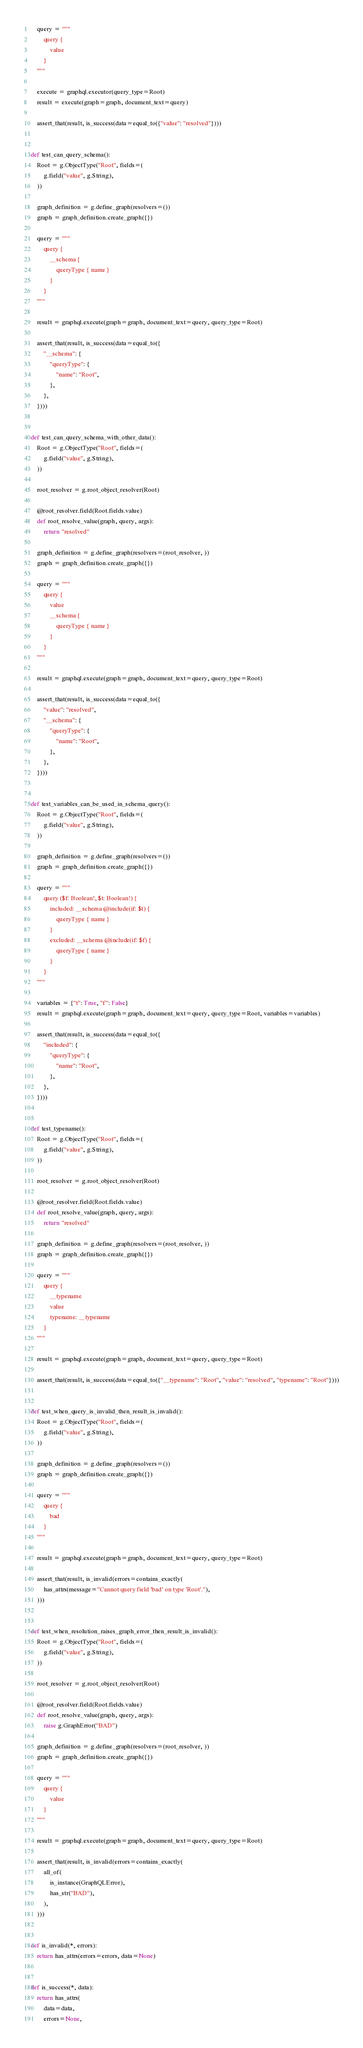Convert code to text. <code><loc_0><loc_0><loc_500><loc_500><_Python_>    query = """
        query {
            value
        }
    """

    execute = graphql.executor(query_type=Root)
    result = execute(graph=graph, document_text=query)

    assert_that(result, is_success(data=equal_to({"value": "resolved"})))


def test_can_query_schema():
    Root = g.ObjectType("Root", fields=(
        g.field("value", g.String),
    ))

    graph_definition = g.define_graph(resolvers=())
    graph = graph_definition.create_graph({})

    query = """
        query {
            __schema {
                queryType { name }
            }
        }
    """

    result = graphql.execute(graph=graph, document_text=query, query_type=Root)

    assert_that(result, is_success(data=equal_to({
        "__schema": {
            "queryType": {
                "name": "Root",
            },
        },
    })))


def test_can_query_schema_with_other_data():
    Root = g.ObjectType("Root", fields=(
        g.field("value", g.String),
    ))

    root_resolver = g.root_object_resolver(Root)

    @root_resolver.field(Root.fields.value)
    def root_resolve_value(graph, query, args):
        return "resolved"

    graph_definition = g.define_graph(resolvers=(root_resolver, ))
    graph = graph_definition.create_graph({})

    query = """
        query {
            value
            __schema {
                queryType { name }
            }
        }
    """

    result = graphql.execute(graph=graph, document_text=query, query_type=Root)

    assert_that(result, is_success(data=equal_to({
        "value": "resolved",
        "__schema": {
            "queryType": {
                "name": "Root",
            },
        },
    })))


def test_variables_can_be_used_in_schema_query():
    Root = g.ObjectType("Root", fields=(
        g.field("value", g.String),
    ))

    graph_definition = g.define_graph(resolvers=())
    graph = graph_definition.create_graph({})

    query = """
        query ($f: Boolean!, $t: Boolean!) {
            included: __schema @include(if: $t) {
                queryType { name }
            }
            excluded: __schema @include(if: $f) {
                queryType { name }
            }
        }
    """

    variables = {"t": True, "f": False}
    result = graphql.execute(graph=graph, document_text=query, query_type=Root, variables=variables)

    assert_that(result, is_success(data=equal_to({
        "included": {
            "queryType": {
                "name": "Root",
            },
        },
    })))


def test_typename():
    Root = g.ObjectType("Root", fields=(
        g.field("value", g.String),
    ))

    root_resolver = g.root_object_resolver(Root)

    @root_resolver.field(Root.fields.value)
    def root_resolve_value(graph, query, args):
        return "resolved"

    graph_definition = g.define_graph(resolvers=(root_resolver, ))
    graph = graph_definition.create_graph({})

    query = """
        query {
            __typename
            value
            typename: __typename
        }
    """

    result = graphql.execute(graph=graph, document_text=query, query_type=Root)

    assert_that(result, is_success(data=equal_to({"__typename": "Root", "value": "resolved", "typename": "Root"})))


def test_when_query_is_invalid_then_result_is_invalid():
    Root = g.ObjectType("Root", fields=(
        g.field("value", g.String),
    ))

    graph_definition = g.define_graph(resolvers=())
    graph = graph_definition.create_graph({})

    query = """
        query {
            bad
        }
    """

    result = graphql.execute(graph=graph, document_text=query, query_type=Root)

    assert_that(result, is_invalid(errors=contains_exactly(
        has_attrs(message="Cannot query field 'bad' on type 'Root'."),
    )))


def test_when_resolution_raises_graph_error_then_result_is_invalid():
    Root = g.ObjectType("Root", fields=(
        g.field("value", g.String),
    ))

    root_resolver = g.root_object_resolver(Root)

    @root_resolver.field(Root.fields.value)
    def root_resolve_value(graph, query, args):
        raise g.GraphError("BAD")

    graph_definition = g.define_graph(resolvers=(root_resolver, ))
    graph = graph_definition.create_graph({})

    query = """
        query {
            value
        }
    """

    result = graphql.execute(graph=graph, document_text=query, query_type=Root)

    assert_that(result, is_invalid(errors=contains_exactly(
        all_of(
            is_instance(GraphQLError),
            has_str("BAD"),
        ),
    )))


def is_invalid(*, errors):
    return has_attrs(errors=errors, data=None)


def is_success(*, data):
    return has_attrs(
        data=data,
        errors=None,</code> 